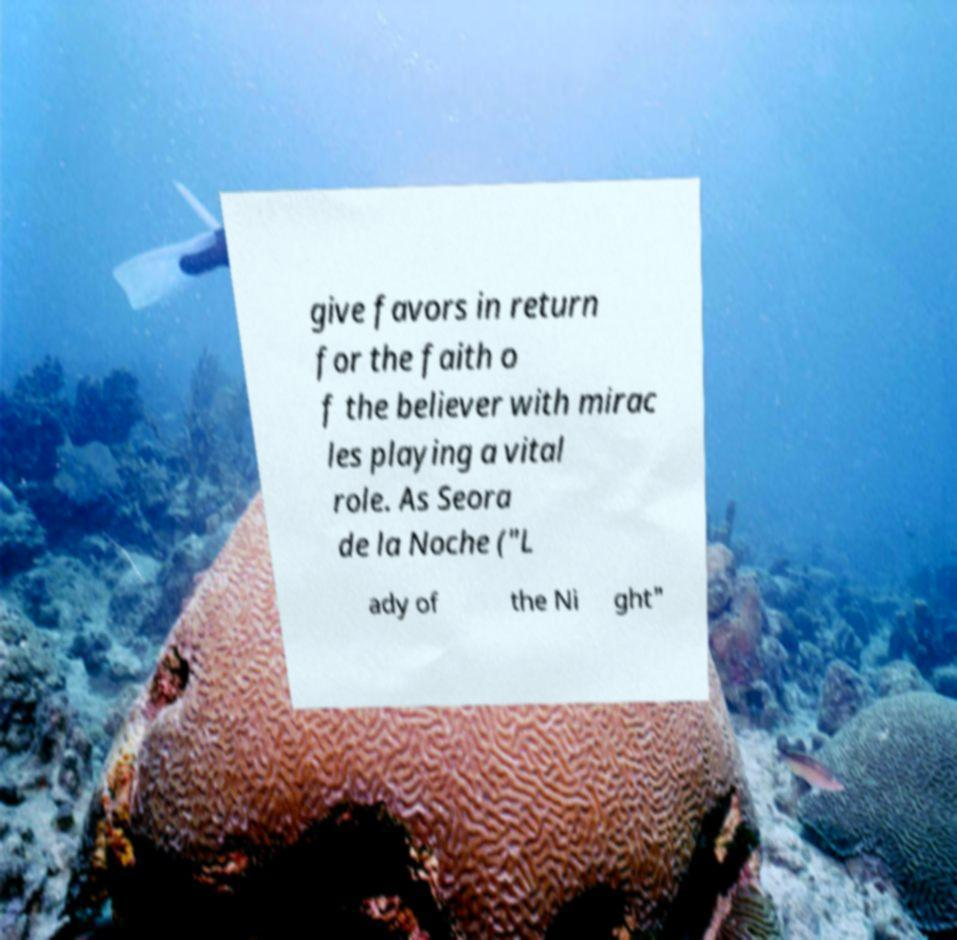Could you assist in decoding the text presented in this image and type it out clearly? give favors in return for the faith o f the believer with mirac les playing a vital role. As Seora de la Noche ("L ady of the Ni ght" 